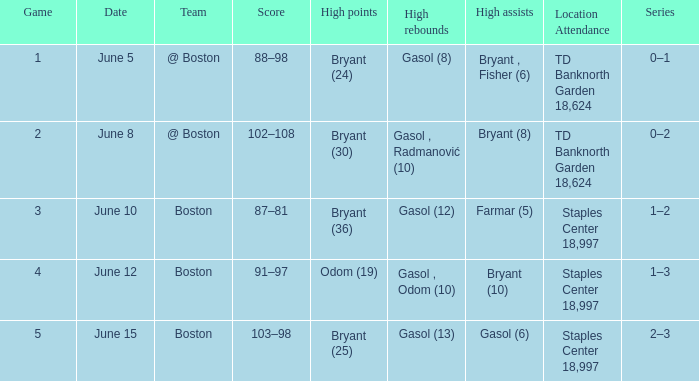Identify the quantity of games on june 1 1.0. 